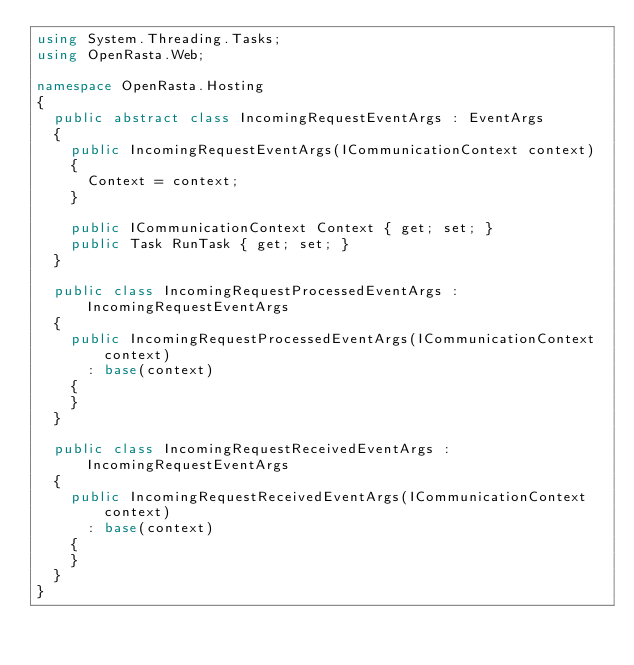Convert code to text. <code><loc_0><loc_0><loc_500><loc_500><_C#_>using System.Threading.Tasks;
using OpenRasta.Web;

namespace OpenRasta.Hosting
{
  public abstract class IncomingRequestEventArgs : EventArgs
  {
    public IncomingRequestEventArgs(ICommunicationContext context)
    {
      Context = context;
    }

    public ICommunicationContext Context { get; set; }
    public Task RunTask { get; set; }
  }

  public class IncomingRequestProcessedEventArgs : IncomingRequestEventArgs
  {
    public IncomingRequestProcessedEventArgs(ICommunicationContext context)
      : base(context)
    {
    }
  }

  public class IncomingRequestReceivedEventArgs : IncomingRequestEventArgs
  {
    public IncomingRequestReceivedEventArgs(ICommunicationContext context)
      : base(context)
    {
    }
  }
}</code> 